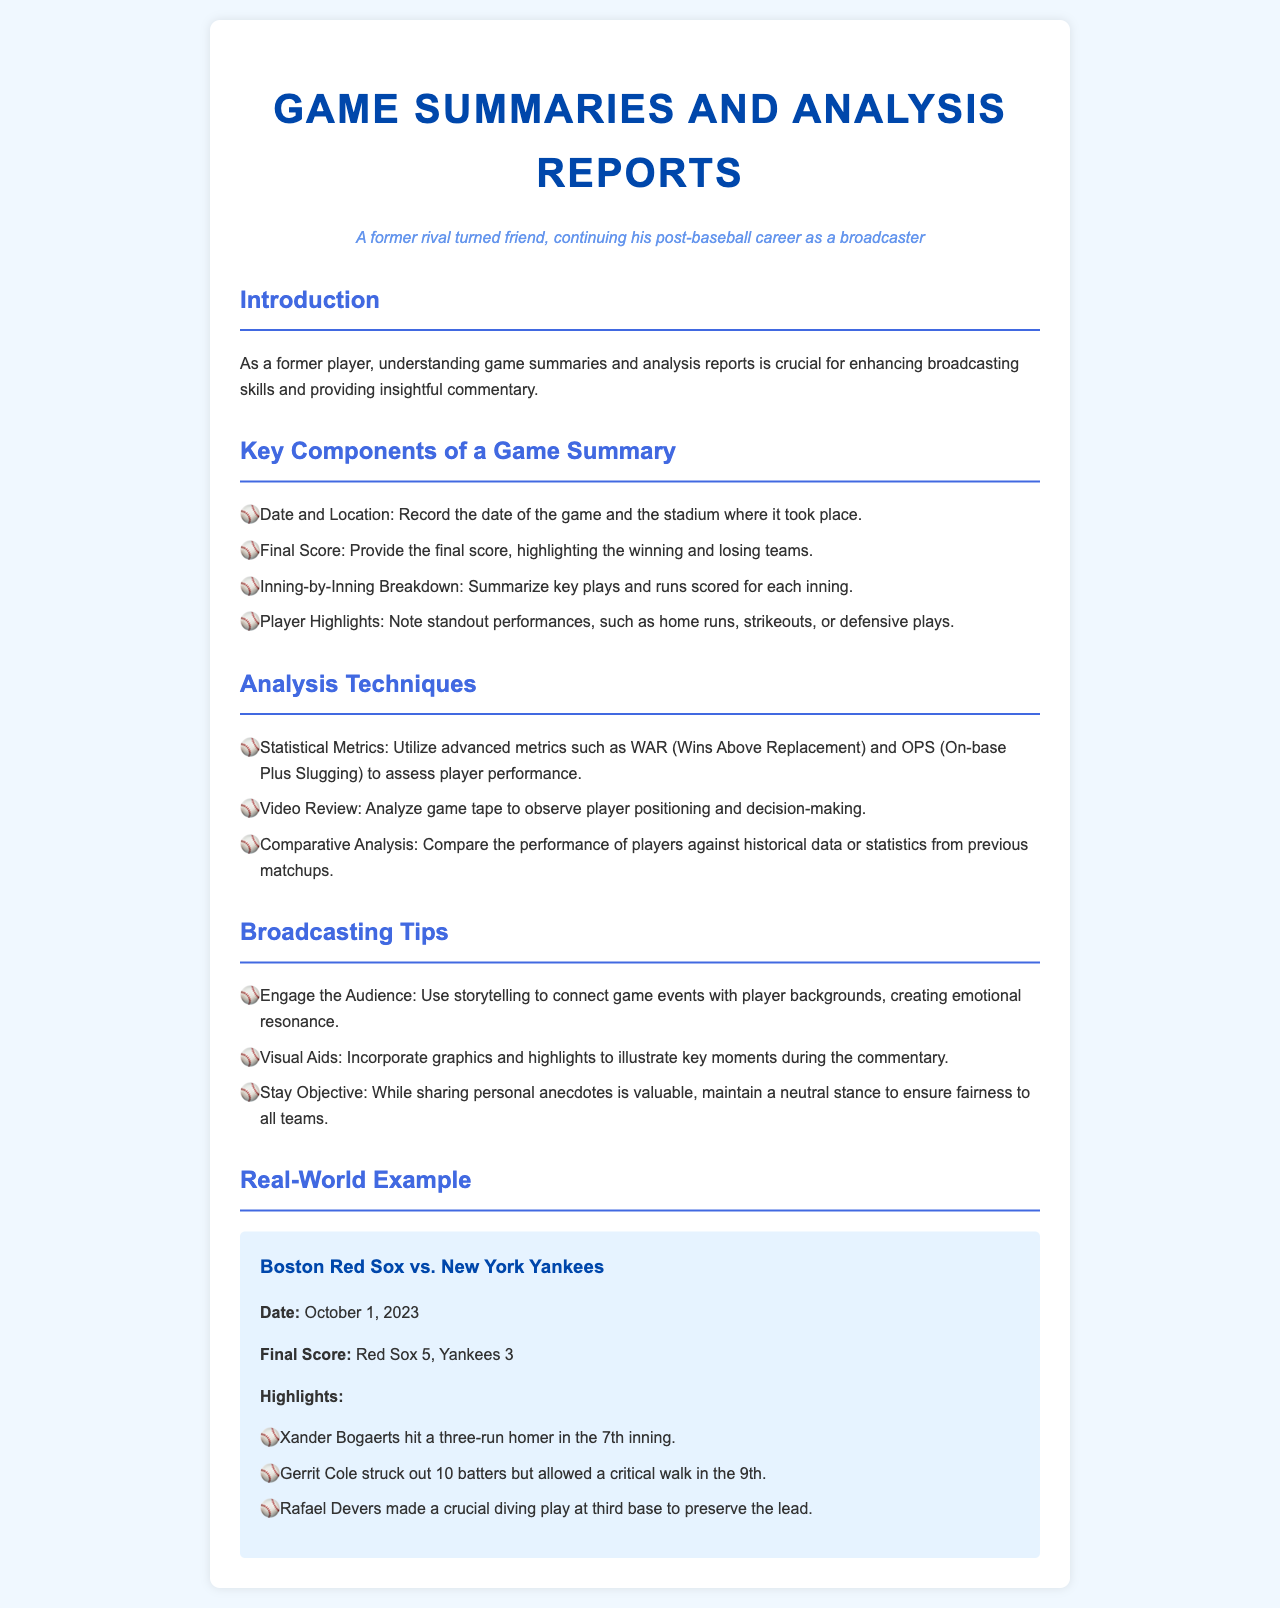What is the title of the document? The title of the document is presented in the header section of the webpage.
Answer: Game Summaries and Analysis Reports What date was the game between the Boston Red Sox and New York Yankees played? The date is located in the real-world example section, which summarizes a specific game.
Answer: October 1, 2023 What was the final score of the game? The final score is included in the highlights of the real-world example section.
Answer: Red Sox 5, Yankees 3 Which player hit a three-run homer? This information is listed under the highlights of the real-world example section.
Answer: Xander Bogaerts What advanced metric is mentioned for assessing player performance? The analysis techniques section discusses various statistical metrics.
Answer: WAR What is one broadcasting tip provided in the document? The broadcasting tips section lists several suggestions for effective commentary.
Answer: Engage the Audience How many batters did Gerrit Cole strike out? This detail is found in the highlights of the real-world example section.
Answer: 10 What is the role of video review in analysis techniques? The analysis techniques section explains various ways to analyze a game.
Answer: Analyze game tape Which player made a crucial diving play? This information is included in the highlights of the real-world example section.
Answer: Rafael Devers 